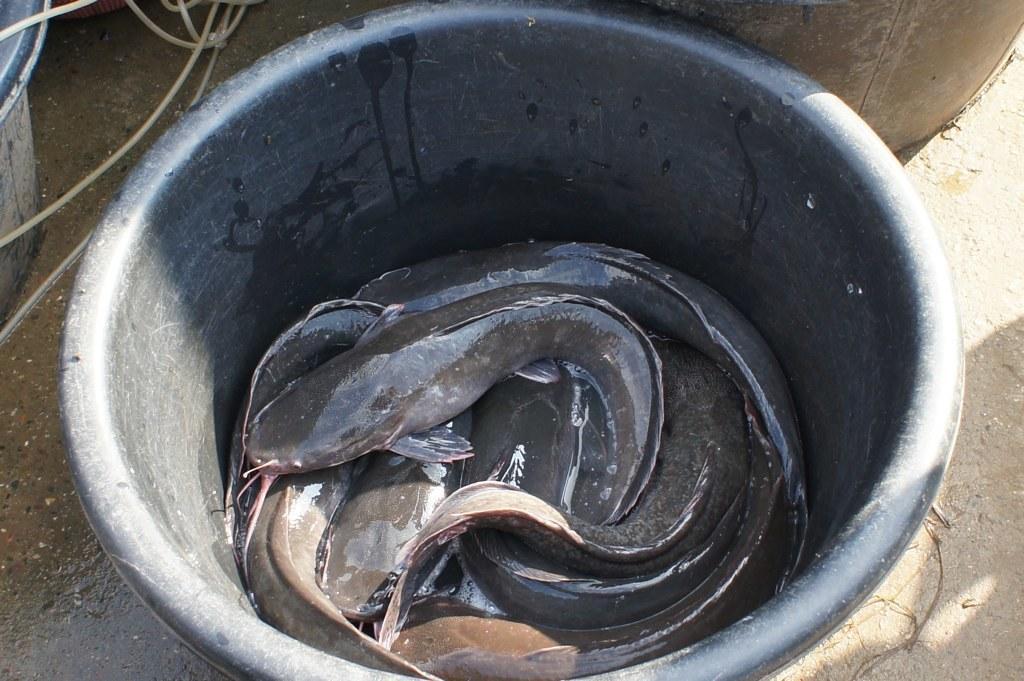Describe this image in one or two sentences. In this image we can see fishes in a black color tub. At the bottom of the image there is floor. To the left side of the image there are wires. 